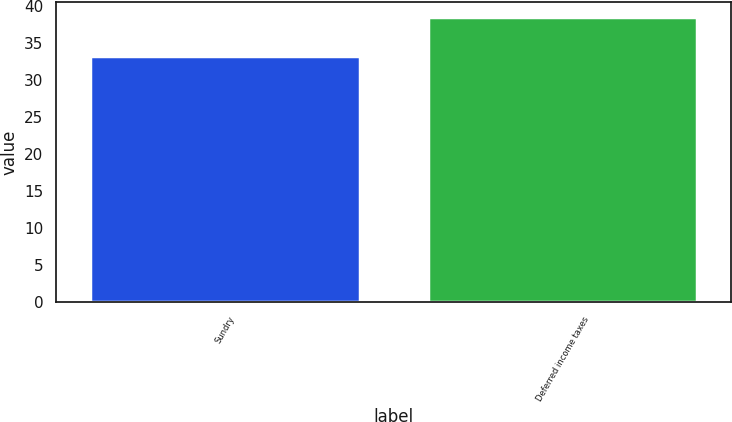Convert chart to OTSL. <chart><loc_0><loc_0><loc_500><loc_500><bar_chart><fcel>Sundry<fcel>Deferred income taxes<nl><fcel>33.3<fcel>38.6<nl></chart> 